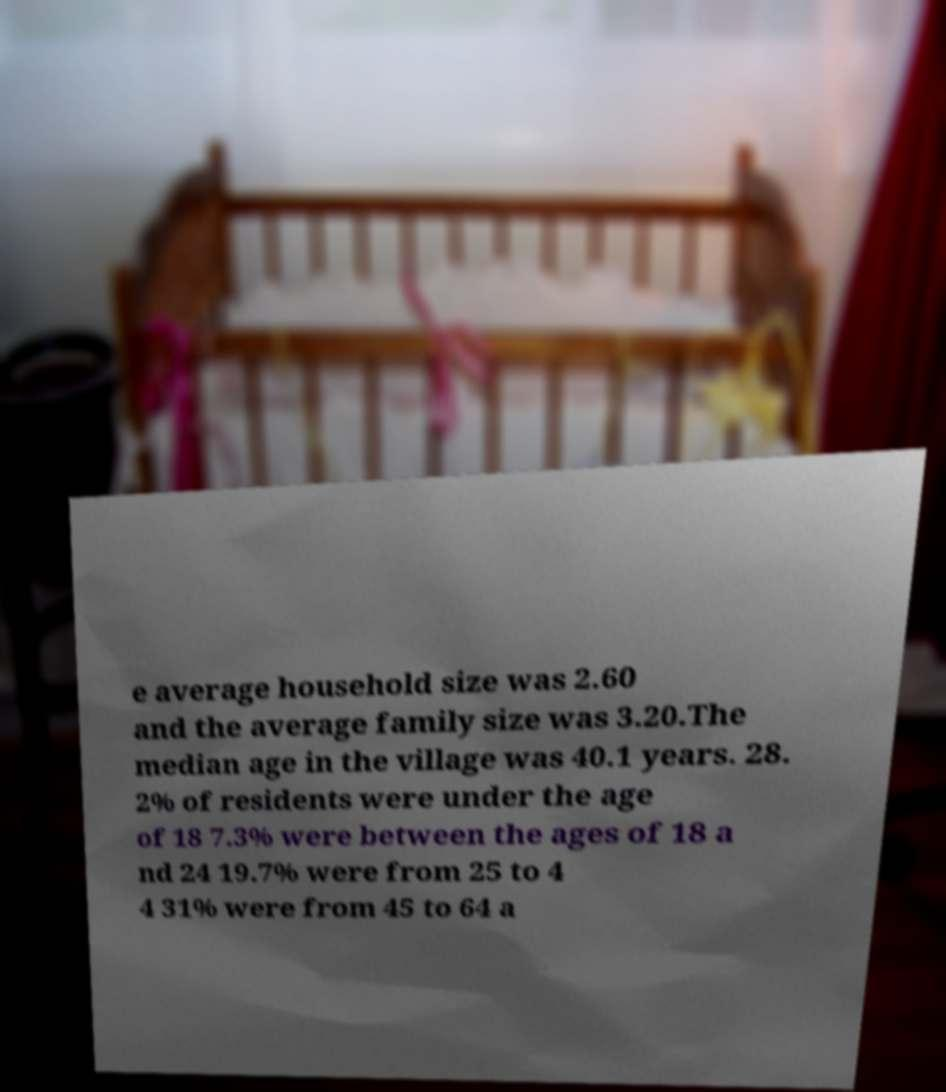There's text embedded in this image that I need extracted. Can you transcribe it verbatim? e average household size was 2.60 and the average family size was 3.20.The median age in the village was 40.1 years. 28. 2% of residents were under the age of 18 7.3% were between the ages of 18 a nd 24 19.7% were from 25 to 4 4 31% were from 45 to 64 a 